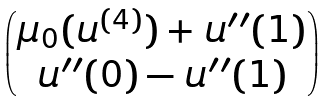Convert formula to latex. <formula><loc_0><loc_0><loc_500><loc_500>\begin{pmatrix} \mu _ { 0 } ( u ^ { ( 4 ) } ) + u ^ { \prime \prime } ( 1 ) \\ u ^ { \prime \prime } ( 0 ) - u ^ { \prime \prime } ( 1 ) \end{pmatrix}</formula> 